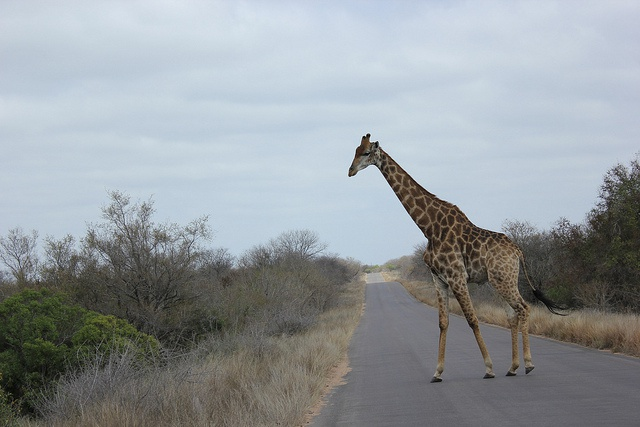Describe the objects in this image and their specific colors. I can see a giraffe in lightgray, gray, and black tones in this image. 